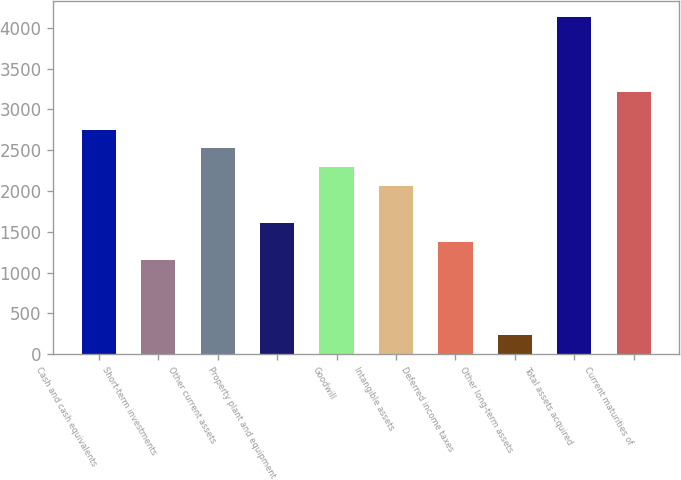Convert chart to OTSL. <chart><loc_0><loc_0><loc_500><loc_500><bar_chart><fcel>Cash and cash equivalents<fcel>Short-term investments<fcel>Other current assets<fcel>Property plant and equipment<fcel>Goodwill<fcel>Intangible assets<fcel>Deferred income taxes<fcel>Other long-term assets<fcel>Total assets acquired<fcel>Current maturities of<nl><fcel>2753.2<fcel>1149.5<fcel>2524.1<fcel>1607.7<fcel>2295<fcel>2065.9<fcel>1378.6<fcel>233.1<fcel>4127.8<fcel>3211.4<nl></chart> 